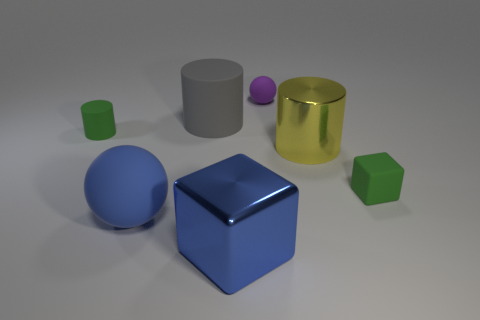Subtract all spheres. How many objects are left? 5 Subtract 2 cubes. How many cubes are left? 0 Subtract all blue blocks. Subtract all brown balls. How many blocks are left? 1 Subtract all blue balls. How many yellow cylinders are left? 1 Subtract all small blue rubber cylinders. Subtract all small purple matte things. How many objects are left? 6 Add 2 gray things. How many gray things are left? 3 Add 1 large gray cylinders. How many large gray cylinders exist? 2 Add 3 gray matte cylinders. How many objects exist? 10 Subtract all gray cylinders. How many cylinders are left? 2 Subtract all gray cylinders. How many cylinders are left? 2 